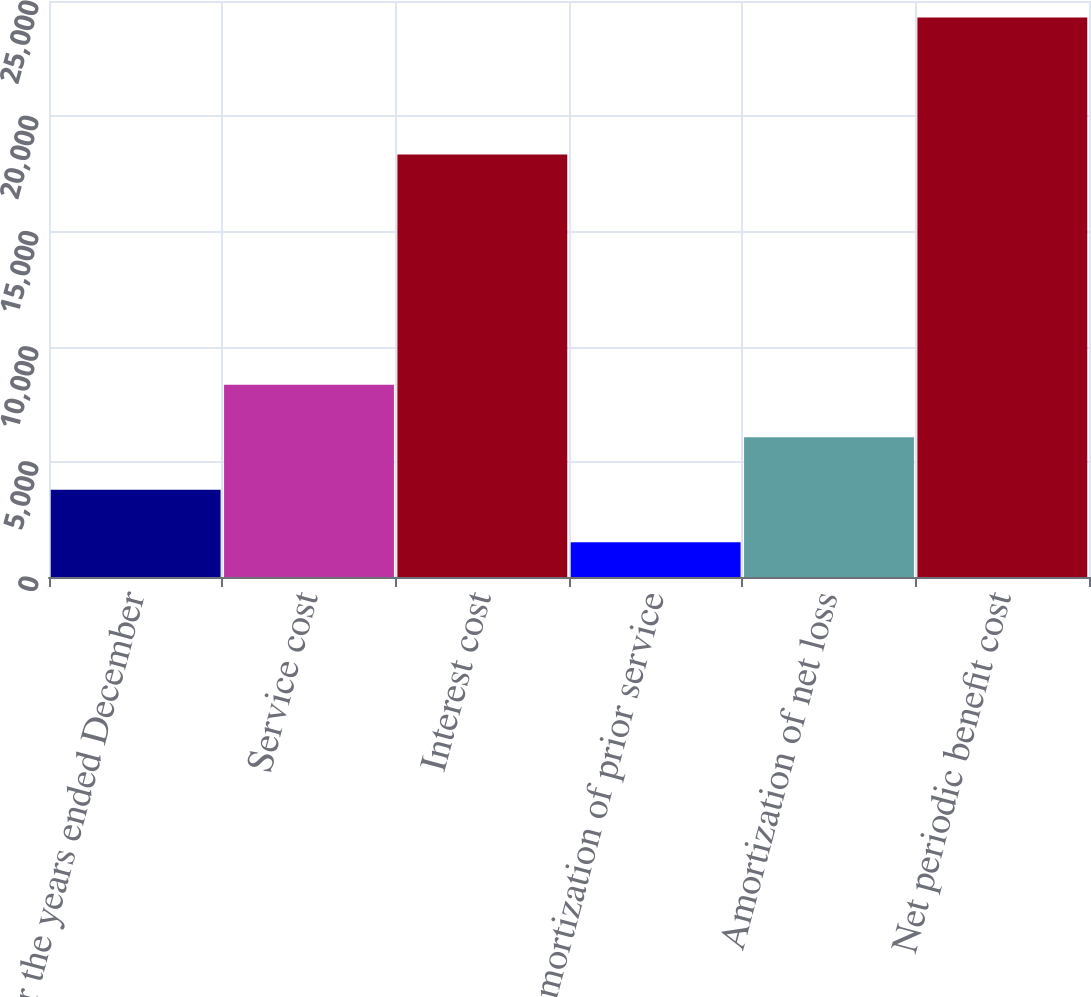Convert chart. <chart><loc_0><loc_0><loc_500><loc_500><bar_chart><fcel>For the years ended December<fcel>Service cost<fcel>Interest cost<fcel>Amortization of prior service<fcel>Amortization of net loss<fcel>Net periodic benefit cost<nl><fcel>3784.3<fcel>8338.9<fcel>18335<fcel>1507<fcel>6061.6<fcel>24280<nl></chart> 